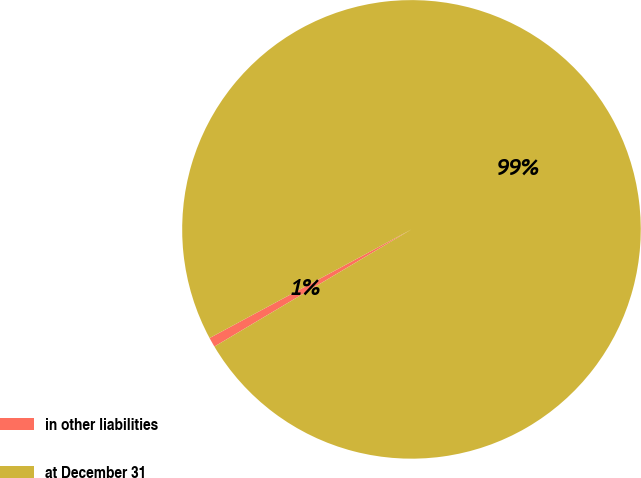Convert chart. <chart><loc_0><loc_0><loc_500><loc_500><pie_chart><fcel>in other liabilities<fcel>at December 31<nl><fcel>0.68%<fcel>99.32%<nl></chart> 